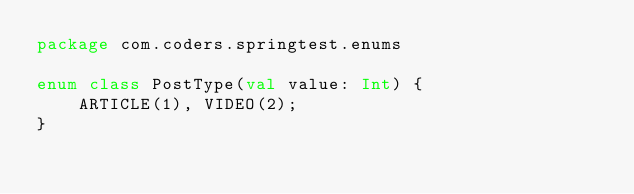Convert code to text. <code><loc_0><loc_0><loc_500><loc_500><_Kotlin_>package com.coders.springtest.enums

enum class PostType(val value: Int) {
    ARTICLE(1), VIDEO(2);
}</code> 